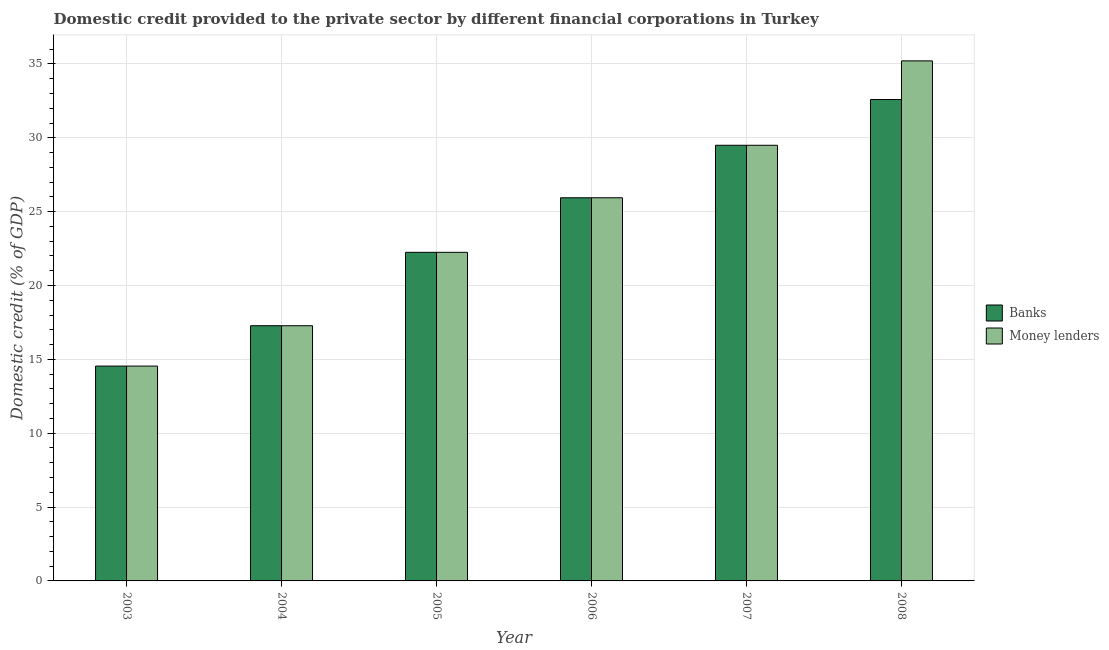How many different coloured bars are there?
Provide a succinct answer. 2. Are the number of bars per tick equal to the number of legend labels?
Offer a very short reply. Yes. How many bars are there on the 3rd tick from the left?
Make the answer very short. 2. What is the label of the 6th group of bars from the left?
Offer a terse response. 2008. In how many cases, is the number of bars for a given year not equal to the number of legend labels?
Your answer should be compact. 0. What is the domestic credit provided by banks in 2008?
Offer a terse response. 32.59. Across all years, what is the maximum domestic credit provided by money lenders?
Offer a very short reply. 35.21. Across all years, what is the minimum domestic credit provided by money lenders?
Keep it short and to the point. 14.55. In which year was the domestic credit provided by banks minimum?
Your response must be concise. 2003. What is the total domestic credit provided by money lenders in the graph?
Provide a short and direct response. 144.72. What is the difference between the domestic credit provided by money lenders in 2003 and that in 2008?
Ensure brevity in your answer.  -20.66. What is the difference between the domestic credit provided by banks in 2008 and the domestic credit provided by money lenders in 2006?
Your answer should be very brief. 6.65. What is the average domestic credit provided by money lenders per year?
Offer a very short reply. 24.12. In the year 2008, what is the difference between the domestic credit provided by money lenders and domestic credit provided by banks?
Ensure brevity in your answer.  0. What is the ratio of the domestic credit provided by money lenders in 2004 to that in 2008?
Keep it short and to the point. 0.49. Is the domestic credit provided by banks in 2007 less than that in 2008?
Offer a terse response. Yes. Is the difference between the domestic credit provided by money lenders in 2005 and 2007 greater than the difference between the domestic credit provided by banks in 2005 and 2007?
Provide a short and direct response. No. What is the difference between the highest and the second highest domestic credit provided by money lenders?
Provide a short and direct response. 5.71. What is the difference between the highest and the lowest domestic credit provided by money lenders?
Give a very brief answer. 20.66. In how many years, is the domestic credit provided by money lenders greater than the average domestic credit provided by money lenders taken over all years?
Ensure brevity in your answer.  3. Is the sum of the domestic credit provided by banks in 2007 and 2008 greater than the maximum domestic credit provided by money lenders across all years?
Your response must be concise. Yes. What does the 2nd bar from the left in 2008 represents?
Make the answer very short. Money lenders. What does the 1st bar from the right in 2008 represents?
Make the answer very short. Money lenders. How many bars are there?
Your answer should be very brief. 12. What is the difference between two consecutive major ticks on the Y-axis?
Give a very brief answer. 5. Are the values on the major ticks of Y-axis written in scientific E-notation?
Ensure brevity in your answer.  No. Does the graph contain grids?
Give a very brief answer. Yes. Where does the legend appear in the graph?
Offer a very short reply. Center right. What is the title of the graph?
Offer a very short reply. Domestic credit provided to the private sector by different financial corporations in Turkey. What is the label or title of the X-axis?
Offer a very short reply. Year. What is the label or title of the Y-axis?
Keep it short and to the point. Domestic credit (% of GDP). What is the Domestic credit (% of GDP) in Banks in 2003?
Your answer should be very brief. 14.55. What is the Domestic credit (% of GDP) of Money lenders in 2003?
Keep it short and to the point. 14.55. What is the Domestic credit (% of GDP) of Banks in 2004?
Make the answer very short. 17.28. What is the Domestic credit (% of GDP) of Money lenders in 2004?
Your answer should be very brief. 17.28. What is the Domestic credit (% of GDP) of Banks in 2005?
Offer a terse response. 22.25. What is the Domestic credit (% of GDP) in Money lenders in 2005?
Your response must be concise. 22.25. What is the Domestic credit (% of GDP) of Banks in 2006?
Your answer should be very brief. 25.94. What is the Domestic credit (% of GDP) in Money lenders in 2006?
Your answer should be compact. 25.94. What is the Domestic credit (% of GDP) of Banks in 2007?
Provide a succinct answer. 29.5. What is the Domestic credit (% of GDP) of Money lenders in 2007?
Your answer should be compact. 29.5. What is the Domestic credit (% of GDP) in Banks in 2008?
Your answer should be compact. 32.59. What is the Domestic credit (% of GDP) of Money lenders in 2008?
Your answer should be compact. 35.21. Across all years, what is the maximum Domestic credit (% of GDP) in Banks?
Your response must be concise. 32.59. Across all years, what is the maximum Domestic credit (% of GDP) of Money lenders?
Your answer should be very brief. 35.21. Across all years, what is the minimum Domestic credit (% of GDP) in Banks?
Keep it short and to the point. 14.55. Across all years, what is the minimum Domestic credit (% of GDP) in Money lenders?
Give a very brief answer. 14.55. What is the total Domestic credit (% of GDP) of Banks in the graph?
Your answer should be very brief. 142.11. What is the total Domestic credit (% of GDP) in Money lenders in the graph?
Keep it short and to the point. 144.72. What is the difference between the Domestic credit (% of GDP) in Banks in 2003 and that in 2004?
Give a very brief answer. -2.73. What is the difference between the Domestic credit (% of GDP) of Money lenders in 2003 and that in 2004?
Your response must be concise. -2.73. What is the difference between the Domestic credit (% of GDP) in Banks in 2003 and that in 2005?
Offer a terse response. -7.7. What is the difference between the Domestic credit (% of GDP) of Money lenders in 2003 and that in 2005?
Offer a terse response. -7.7. What is the difference between the Domestic credit (% of GDP) in Banks in 2003 and that in 2006?
Give a very brief answer. -11.4. What is the difference between the Domestic credit (% of GDP) of Money lenders in 2003 and that in 2006?
Your response must be concise. -11.4. What is the difference between the Domestic credit (% of GDP) in Banks in 2003 and that in 2007?
Offer a terse response. -14.95. What is the difference between the Domestic credit (% of GDP) in Money lenders in 2003 and that in 2007?
Provide a succinct answer. -14.95. What is the difference between the Domestic credit (% of GDP) of Banks in 2003 and that in 2008?
Offer a terse response. -18.05. What is the difference between the Domestic credit (% of GDP) in Money lenders in 2003 and that in 2008?
Offer a terse response. -20.66. What is the difference between the Domestic credit (% of GDP) of Banks in 2004 and that in 2005?
Keep it short and to the point. -4.97. What is the difference between the Domestic credit (% of GDP) of Money lenders in 2004 and that in 2005?
Provide a succinct answer. -4.97. What is the difference between the Domestic credit (% of GDP) of Banks in 2004 and that in 2006?
Keep it short and to the point. -8.66. What is the difference between the Domestic credit (% of GDP) of Money lenders in 2004 and that in 2006?
Your response must be concise. -8.66. What is the difference between the Domestic credit (% of GDP) in Banks in 2004 and that in 2007?
Keep it short and to the point. -12.22. What is the difference between the Domestic credit (% of GDP) of Money lenders in 2004 and that in 2007?
Offer a very short reply. -12.22. What is the difference between the Domestic credit (% of GDP) of Banks in 2004 and that in 2008?
Offer a terse response. -15.32. What is the difference between the Domestic credit (% of GDP) in Money lenders in 2004 and that in 2008?
Give a very brief answer. -17.93. What is the difference between the Domestic credit (% of GDP) of Banks in 2005 and that in 2006?
Provide a succinct answer. -3.69. What is the difference between the Domestic credit (% of GDP) of Money lenders in 2005 and that in 2006?
Ensure brevity in your answer.  -3.69. What is the difference between the Domestic credit (% of GDP) of Banks in 2005 and that in 2007?
Make the answer very short. -7.25. What is the difference between the Domestic credit (% of GDP) in Money lenders in 2005 and that in 2007?
Keep it short and to the point. -7.25. What is the difference between the Domestic credit (% of GDP) in Banks in 2005 and that in 2008?
Offer a terse response. -10.35. What is the difference between the Domestic credit (% of GDP) in Money lenders in 2005 and that in 2008?
Offer a terse response. -12.96. What is the difference between the Domestic credit (% of GDP) of Banks in 2006 and that in 2007?
Your response must be concise. -3.55. What is the difference between the Domestic credit (% of GDP) of Money lenders in 2006 and that in 2007?
Offer a terse response. -3.55. What is the difference between the Domestic credit (% of GDP) in Banks in 2006 and that in 2008?
Offer a terse response. -6.65. What is the difference between the Domestic credit (% of GDP) of Money lenders in 2006 and that in 2008?
Provide a succinct answer. -9.27. What is the difference between the Domestic credit (% of GDP) in Banks in 2007 and that in 2008?
Your response must be concise. -3.1. What is the difference between the Domestic credit (% of GDP) in Money lenders in 2007 and that in 2008?
Your answer should be very brief. -5.71. What is the difference between the Domestic credit (% of GDP) in Banks in 2003 and the Domestic credit (% of GDP) in Money lenders in 2004?
Offer a terse response. -2.73. What is the difference between the Domestic credit (% of GDP) of Banks in 2003 and the Domestic credit (% of GDP) of Money lenders in 2005?
Your answer should be very brief. -7.7. What is the difference between the Domestic credit (% of GDP) in Banks in 2003 and the Domestic credit (% of GDP) in Money lenders in 2006?
Provide a short and direct response. -11.4. What is the difference between the Domestic credit (% of GDP) in Banks in 2003 and the Domestic credit (% of GDP) in Money lenders in 2007?
Offer a terse response. -14.95. What is the difference between the Domestic credit (% of GDP) in Banks in 2003 and the Domestic credit (% of GDP) in Money lenders in 2008?
Provide a short and direct response. -20.66. What is the difference between the Domestic credit (% of GDP) in Banks in 2004 and the Domestic credit (% of GDP) in Money lenders in 2005?
Offer a very short reply. -4.97. What is the difference between the Domestic credit (% of GDP) of Banks in 2004 and the Domestic credit (% of GDP) of Money lenders in 2006?
Ensure brevity in your answer.  -8.66. What is the difference between the Domestic credit (% of GDP) in Banks in 2004 and the Domestic credit (% of GDP) in Money lenders in 2007?
Give a very brief answer. -12.22. What is the difference between the Domestic credit (% of GDP) of Banks in 2004 and the Domestic credit (% of GDP) of Money lenders in 2008?
Your answer should be compact. -17.93. What is the difference between the Domestic credit (% of GDP) in Banks in 2005 and the Domestic credit (% of GDP) in Money lenders in 2006?
Offer a terse response. -3.69. What is the difference between the Domestic credit (% of GDP) in Banks in 2005 and the Domestic credit (% of GDP) in Money lenders in 2007?
Ensure brevity in your answer.  -7.25. What is the difference between the Domestic credit (% of GDP) of Banks in 2005 and the Domestic credit (% of GDP) of Money lenders in 2008?
Ensure brevity in your answer.  -12.96. What is the difference between the Domestic credit (% of GDP) in Banks in 2006 and the Domestic credit (% of GDP) in Money lenders in 2007?
Provide a short and direct response. -3.55. What is the difference between the Domestic credit (% of GDP) of Banks in 2006 and the Domestic credit (% of GDP) of Money lenders in 2008?
Provide a short and direct response. -9.27. What is the difference between the Domestic credit (% of GDP) of Banks in 2007 and the Domestic credit (% of GDP) of Money lenders in 2008?
Provide a short and direct response. -5.71. What is the average Domestic credit (% of GDP) of Banks per year?
Your response must be concise. 23.68. What is the average Domestic credit (% of GDP) in Money lenders per year?
Your answer should be compact. 24.12. In the year 2005, what is the difference between the Domestic credit (% of GDP) in Banks and Domestic credit (% of GDP) in Money lenders?
Your answer should be very brief. 0. In the year 2006, what is the difference between the Domestic credit (% of GDP) in Banks and Domestic credit (% of GDP) in Money lenders?
Your response must be concise. 0. In the year 2007, what is the difference between the Domestic credit (% of GDP) in Banks and Domestic credit (% of GDP) in Money lenders?
Keep it short and to the point. 0. In the year 2008, what is the difference between the Domestic credit (% of GDP) of Banks and Domestic credit (% of GDP) of Money lenders?
Provide a succinct answer. -2.62. What is the ratio of the Domestic credit (% of GDP) in Banks in 2003 to that in 2004?
Keep it short and to the point. 0.84. What is the ratio of the Domestic credit (% of GDP) of Money lenders in 2003 to that in 2004?
Offer a very short reply. 0.84. What is the ratio of the Domestic credit (% of GDP) of Banks in 2003 to that in 2005?
Provide a short and direct response. 0.65. What is the ratio of the Domestic credit (% of GDP) in Money lenders in 2003 to that in 2005?
Ensure brevity in your answer.  0.65. What is the ratio of the Domestic credit (% of GDP) in Banks in 2003 to that in 2006?
Provide a succinct answer. 0.56. What is the ratio of the Domestic credit (% of GDP) in Money lenders in 2003 to that in 2006?
Ensure brevity in your answer.  0.56. What is the ratio of the Domestic credit (% of GDP) in Banks in 2003 to that in 2007?
Offer a terse response. 0.49. What is the ratio of the Domestic credit (% of GDP) in Money lenders in 2003 to that in 2007?
Give a very brief answer. 0.49. What is the ratio of the Domestic credit (% of GDP) of Banks in 2003 to that in 2008?
Keep it short and to the point. 0.45. What is the ratio of the Domestic credit (% of GDP) of Money lenders in 2003 to that in 2008?
Offer a terse response. 0.41. What is the ratio of the Domestic credit (% of GDP) of Banks in 2004 to that in 2005?
Keep it short and to the point. 0.78. What is the ratio of the Domestic credit (% of GDP) of Money lenders in 2004 to that in 2005?
Your answer should be compact. 0.78. What is the ratio of the Domestic credit (% of GDP) in Banks in 2004 to that in 2006?
Provide a succinct answer. 0.67. What is the ratio of the Domestic credit (% of GDP) of Money lenders in 2004 to that in 2006?
Provide a short and direct response. 0.67. What is the ratio of the Domestic credit (% of GDP) of Banks in 2004 to that in 2007?
Your answer should be compact. 0.59. What is the ratio of the Domestic credit (% of GDP) of Money lenders in 2004 to that in 2007?
Ensure brevity in your answer.  0.59. What is the ratio of the Domestic credit (% of GDP) of Banks in 2004 to that in 2008?
Make the answer very short. 0.53. What is the ratio of the Domestic credit (% of GDP) of Money lenders in 2004 to that in 2008?
Offer a terse response. 0.49. What is the ratio of the Domestic credit (% of GDP) of Banks in 2005 to that in 2006?
Offer a terse response. 0.86. What is the ratio of the Domestic credit (% of GDP) of Money lenders in 2005 to that in 2006?
Your response must be concise. 0.86. What is the ratio of the Domestic credit (% of GDP) in Banks in 2005 to that in 2007?
Offer a very short reply. 0.75. What is the ratio of the Domestic credit (% of GDP) in Money lenders in 2005 to that in 2007?
Your response must be concise. 0.75. What is the ratio of the Domestic credit (% of GDP) in Banks in 2005 to that in 2008?
Ensure brevity in your answer.  0.68. What is the ratio of the Domestic credit (% of GDP) of Money lenders in 2005 to that in 2008?
Provide a short and direct response. 0.63. What is the ratio of the Domestic credit (% of GDP) in Banks in 2006 to that in 2007?
Keep it short and to the point. 0.88. What is the ratio of the Domestic credit (% of GDP) of Money lenders in 2006 to that in 2007?
Keep it short and to the point. 0.88. What is the ratio of the Domestic credit (% of GDP) of Banks in 2006 to that in 2008?
Provide a succinct answer. 0.8. What is the ratio of the Domestic credit (% of GDP) of Money lenders in 2006 to that in 2008?
Keep it short and to the point. 0.74. What is the ratio of the Domestic credit (% of GDP) of Banks in 2007 to that in 2008?
Offer a terse response. 0.91. What is the ratio of the Domestic credit (% of GDP) in Money lenders in 2007 to that in 2008?
Your response must be concise. 0.84. What is the difference between the highest and the second highest Domestic credit (% of GDP) of Banks?
Your answer should be compact. 3.1. What is the difference between the highest and the second highest Domestic credit (% of GDP) of Money lenders?
Give a very brief answer. 5.71. What is the difference between the highest and the lowest Domestic credit (% of GDP) of Banks?
Offer a very short reply. 18.05. What is the difference between the highest and the lowest Domestic credit (% of GDP) of Money lenders?
Offer a very short reply. 20.66. 